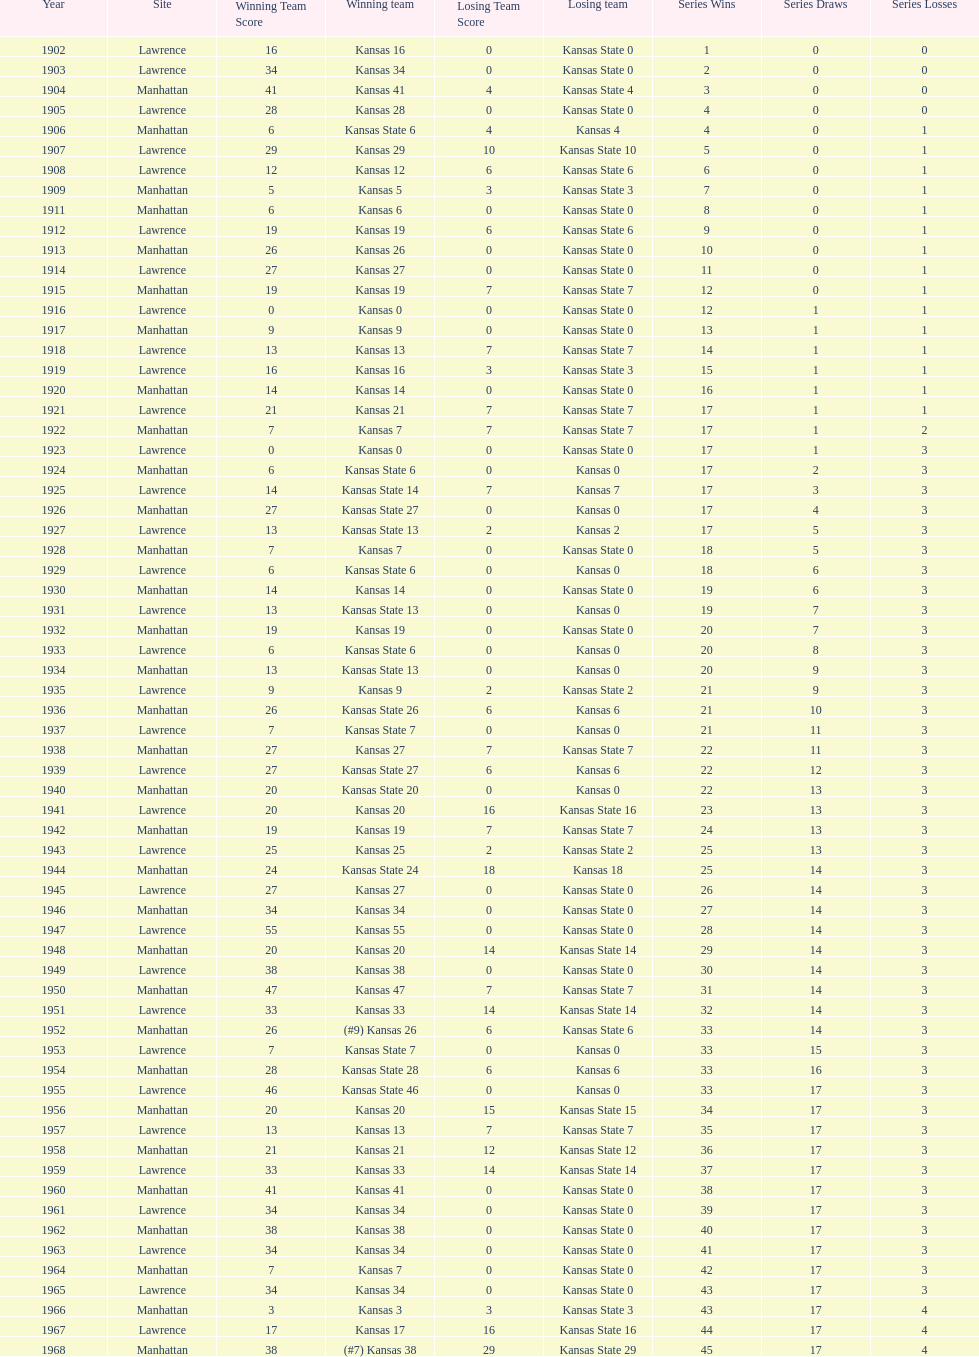How many times did kansas and kansas state play in lawrence from 1902-1968? 34. 